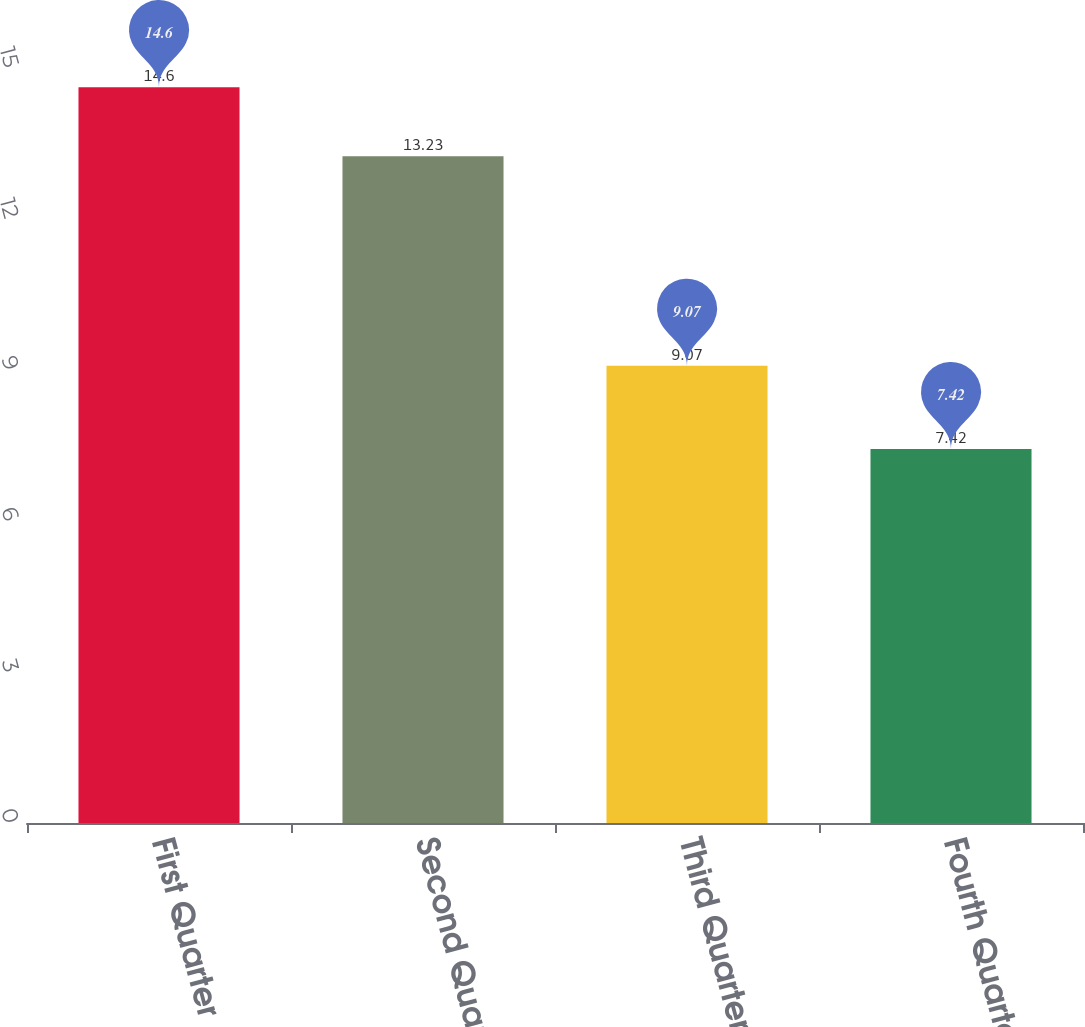<chart> <loc_0><loc_0><loc_500><loc_500><bar_chart><fcel>First Quarter<fcel>Second Quarter<fcel>Third Quarter<fcel>Fourth Quarter<nl><fcel>14.6<fcel>13.23<fcel>9.07<fcel>7.42<nl></chart> 